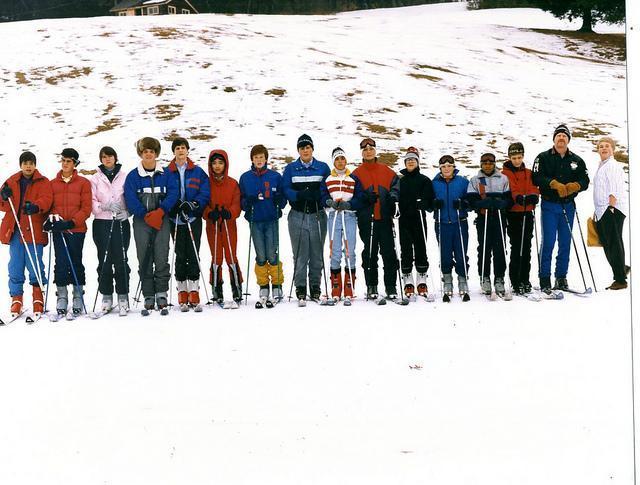How many people are in the picture?
Give a very brief answer. 14. How many forks are there?
Give a very brief answer. 0. 